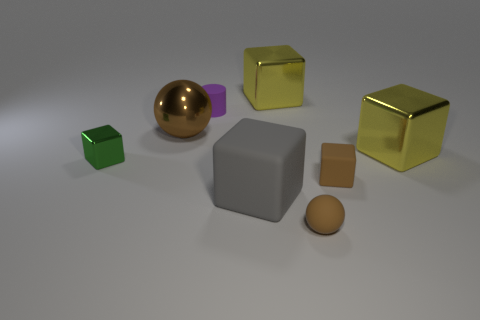Can you describe the colors of the objects? Certainly! In the image, there are objects in green, purple, gold, and varying shades of brown and gray. 